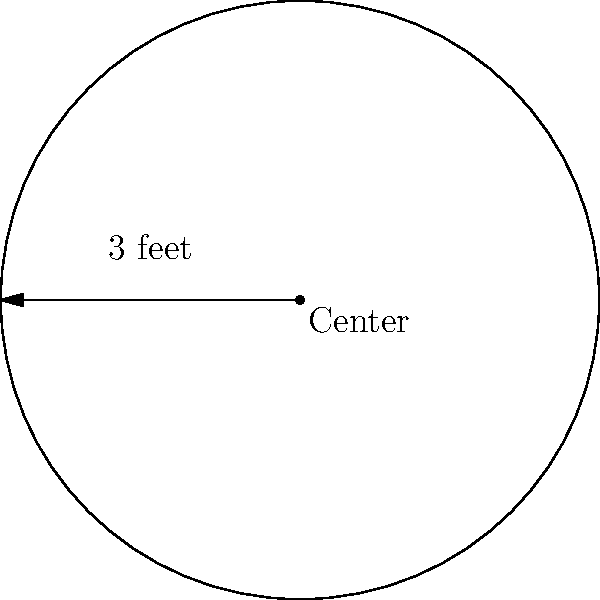Miss Johnson wants to buy a new circular story-time rug for her classroom. The rug has a radius of 3 feet. What is the area of the rug? Let's solve this step-by-step:

1. We know that the formula for the area of a circle is:
   $$A = \pi r^2$$
   Where $A$ is the area and $r$ is the radius.

2. We're given that the radius is 3 feet.

3. Let's substitute this into our formula:
   $$A = \pi (3)^2$$

4. First, let's calculate $3^2$:
   $$A = \pi (9)$$

5. Now, let's multiply by $\pi$:
   $$A = 28.27$$ (rounded to two decimal places)

6. Don't forget the units! The area is in square feet.

So, the area of the story-time rug is approximately 28.27 square feet.
Answer: 28.27 square feet 